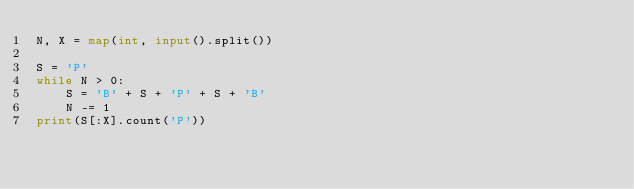<code> <loc_0><loc_0><loc_500><loc_500><_Python_>N, X = map(int, input().split())

S = 'P'
while N > 0:
    S = 'B' + S + 'P' + S + 'B'
    N -= 1
print(S[:X].count('P'))</code> 